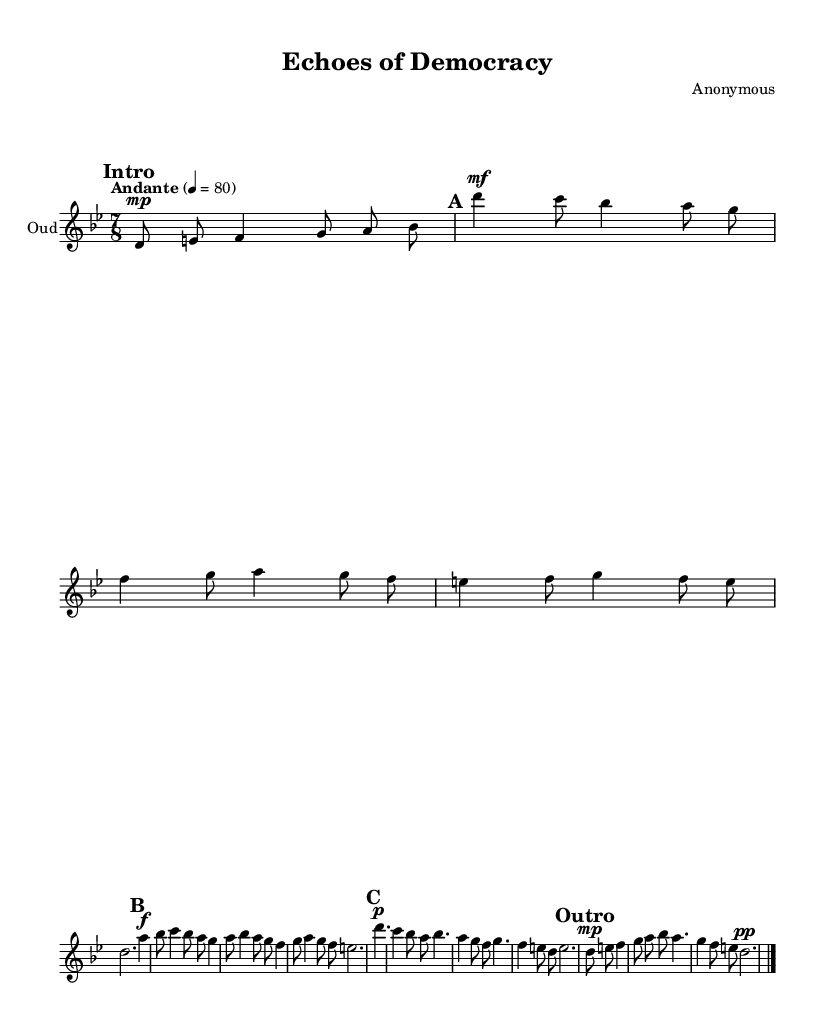What is the key signature of this music? The key signature is indicated at the beginning of the sheet music, showing "d" which signifies D phrygian, meaning there are two flats (B and E) in its scale.
Answer: D phrygian What is the time signature of this music? The time signature appears at the beginning as "7/8," which indicates that there are seven eighth notes in each measure.
Answer: 7/8 What is the tempo marking for this composition? The tempo marking is placed prominently in the score, stating "Andante" followed by "4 = 80," meaning it should be played at a moderate speed of 80 BPM (beats per minute).
Answer: Andante 4 = 80 How many main sections are there in this composition? By examining the structure of the score, there are clearly three main sections labeled as A, B, and C, with an additional Intro and Outro.
Answer: Five What dynamics are indicated in the B section? The B section shows "f" which stands for forte, indicating that this portion should be played loudly, while the rest of the dynamics indicate layers of intensity varying from "mf" (mezzo-forte) to "g" (piano).
Answer: forte What is the overall mood suggested by the dynamic markings throughout the piece? The dynamic markings alternate between softer and louder sections, suggesting a reflective and expressive mood, indicative of the emotional complexity often associated with themes of democracy and representation in Middle Eastern music.
Answer: Reflective 